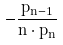<formula> <loc_0><loc_0><loc_500><loc_500>- \frac { p _ { n - 1 } } { n \cdot p _ { n } }</formula> 